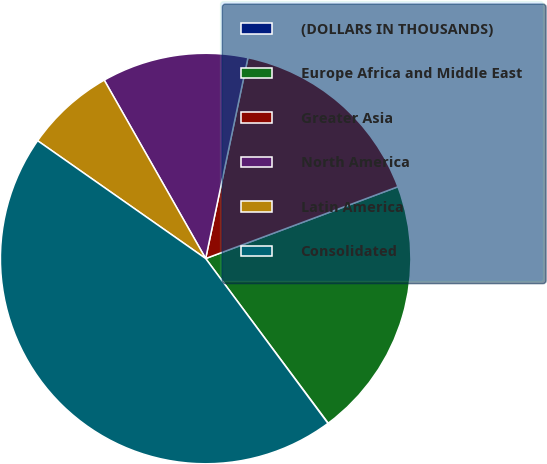<chart> <loc_0><loc_0><loc_500><loc_500><pie_chart><fcel>(DOLLARS IN THOUSANDS)<fcel>Europe Africa and Middle East<fcel>Greater Asia<fcel>North America<fcel>Latin America<fcel>Consolidated<nl><fcel>0.03%<fcel>20.5%<fcel>16.01%<fcel>11.53%<fcel>7.04%<fcel>44.89%<nl></chart> 